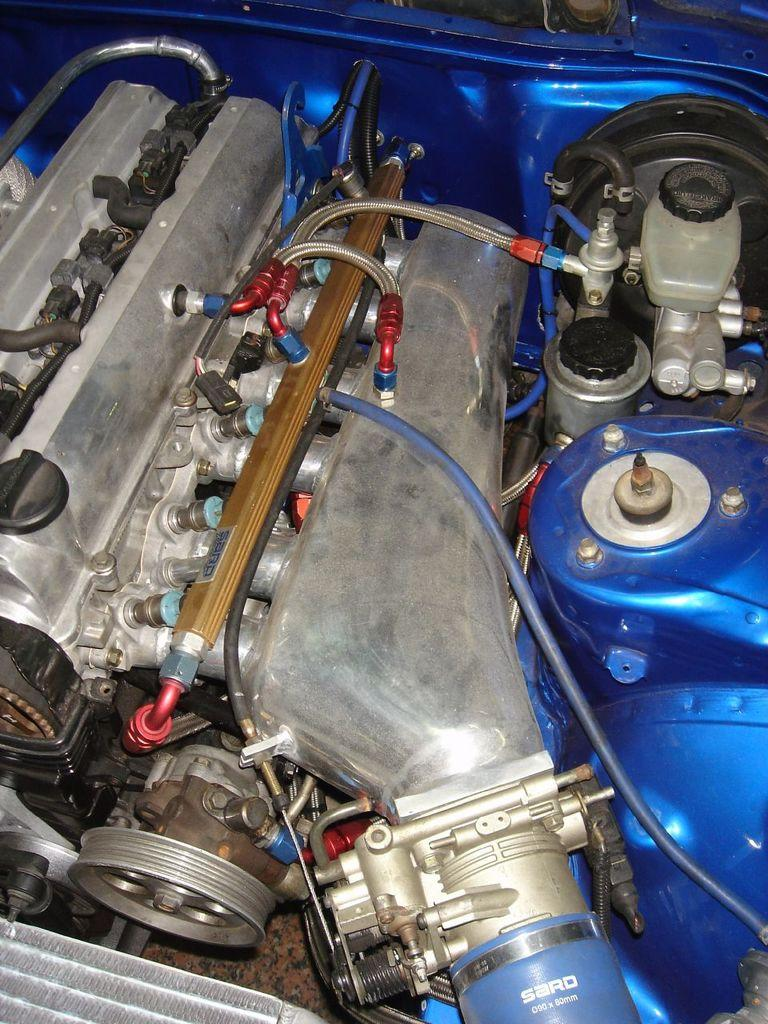What is the main subject of the image? The main subject of the image is an engine. What other objects can be seen in the image? There are pipes and blue-colored things visible in the image. Can you tell me how many spots are on the engine in the image? There are no spots visible on the engine in the image. What type of wing is attached to the engine in the image? There is no wing attached to the engine in the image. 